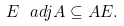Convert formula to latex. <formula><loc_0><loc_0><loc_500><loc_500>E \ a d j A \subseteq A E .</formula> 